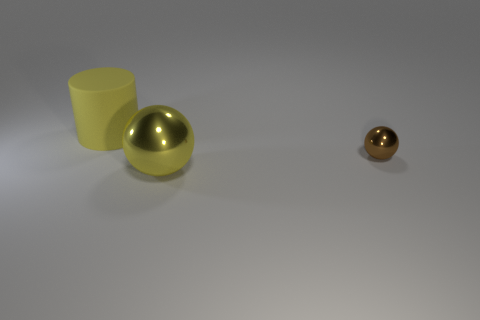Subtract all gray cylinders. Subtract all cyan spheres. How many cylinders are left? 1 Add 1 yellow objects. How many objects exist? 4 Subtract all cylinders. How many objects are left? 2 Add 1 tiny brown balls. How many tiny brown balls are left? 2 Add 1 tiny rubber cubes. How many tiny rubber cubes exist? 1 Subtract 1 yellow cylinders. How many objects are left? 2 Subtract all big cylinders. Subtract all tiny metal balls. How many objects are left? 1 